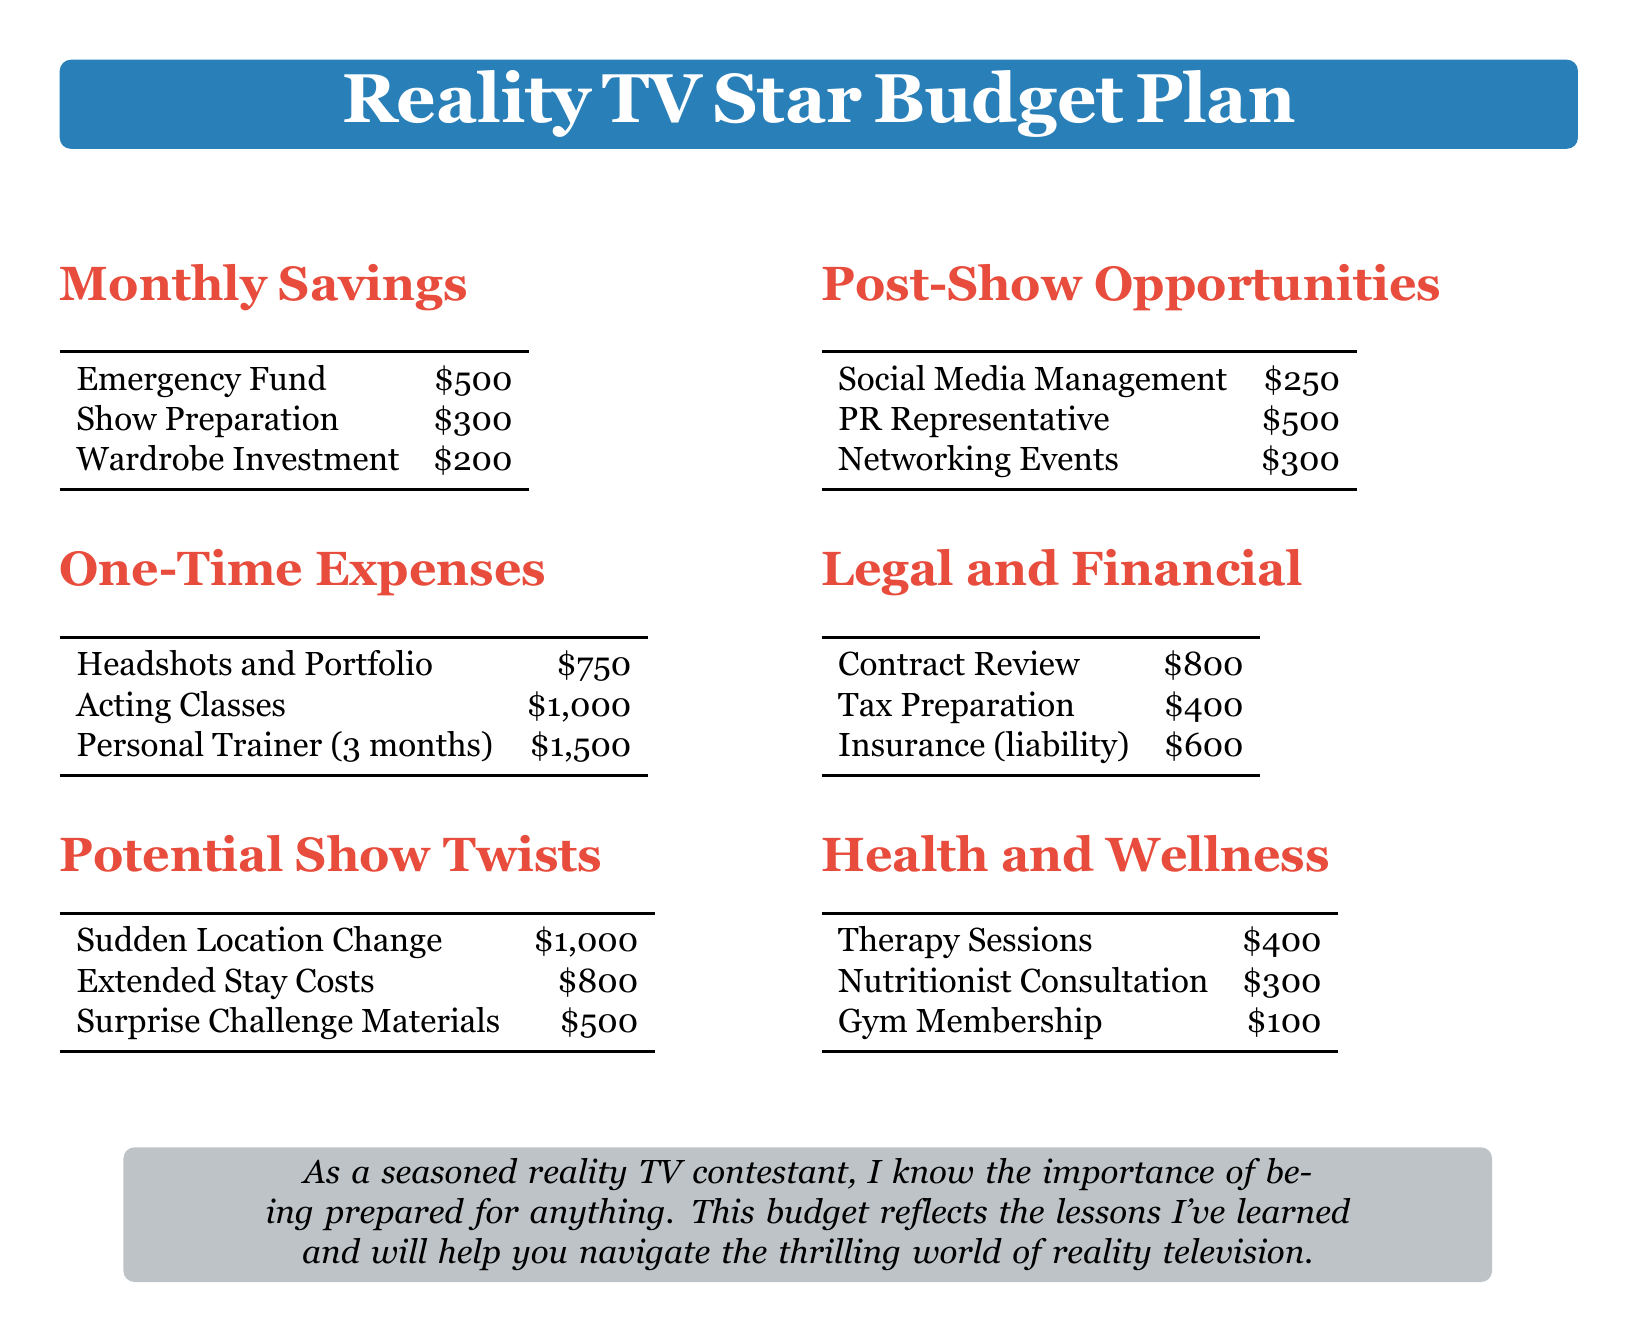What is the amount allocated for the emergency fund? The document specifies that the emergency fund has a budget of $500.
Answer: $500 What is the cost for headshots and portfolio? The headshots and portfolio are listed as a one-time expense costing $750.
Answer: $750 How much is set aside for wardrobe investment monthly? The monthly savings plan includes a wardrobe investment of $200.
Answer: $200 What is the total cost for surprise challenge materials? The surprise challenge materials are budgeted at $500 under potential show twists.
Answer: $500 How much is needed for tax preparation in the legal and financial section? The budget indicates that tax preparation costs $400.
Answer: $400 What is the total amount allocated for health and wellness expenses? The sum of health and wellness expenses is $400 + $300 + $100 = $800.
Answer: $800 How much is the investment for acting classes? The document states that acting classes will cost $1,000 under one-time expenses.
Answer: $1,000 What is included in the post-show opportunities section? The post-show opportunities section includes social media management, PR representative, and networking events expenses.
Answer: Social Media Management, PR Representative, Networking Events What is the total estimated cost for surprised location change and extended stay costs? The total for both is $1,000 for sudden location change and $800 for extended stay costs, summing to $1,800.
Answer: $1,800 